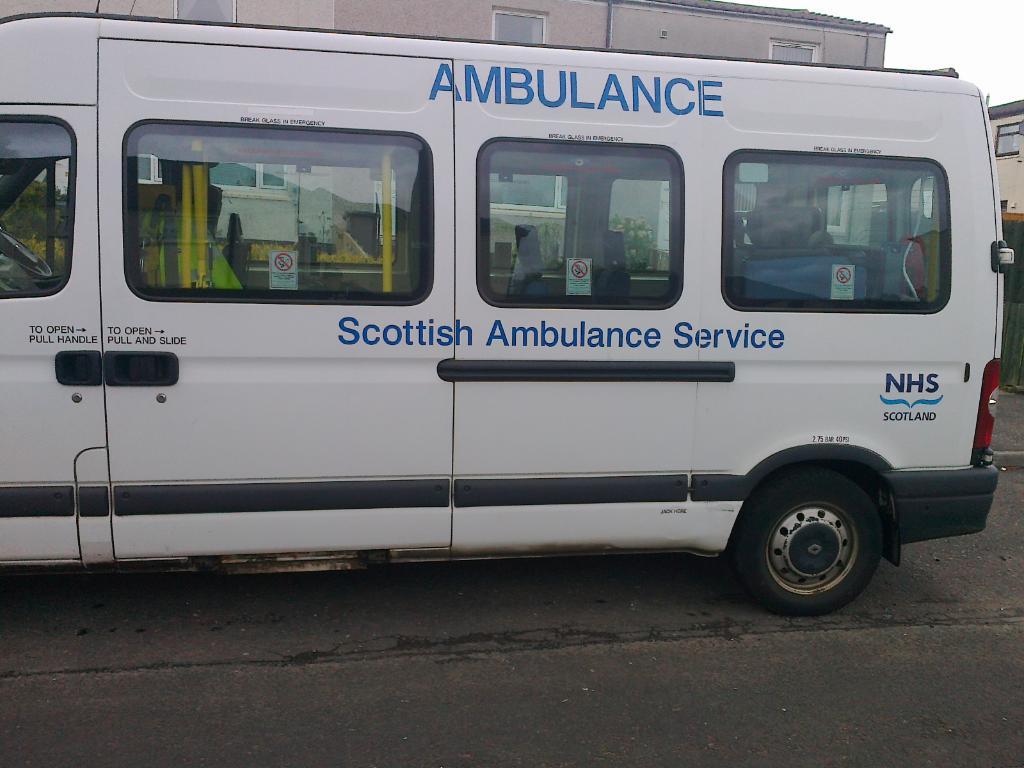What type of ambulance service is this?
Offer a very short reply. Scottish. What government entity provided this ambulance?
Your answer should be compact. Scottish. 